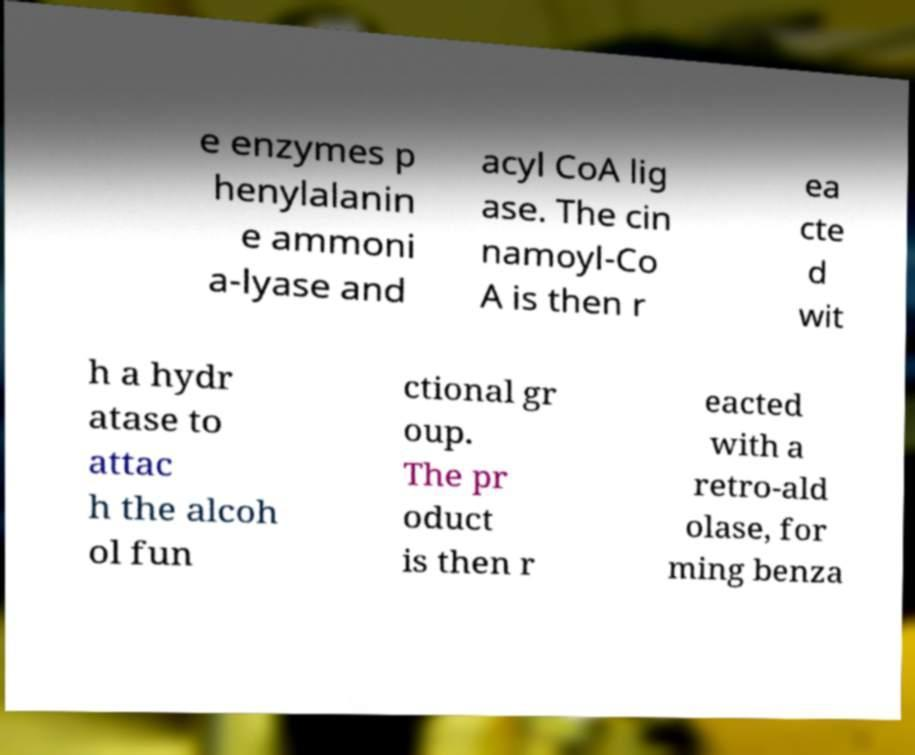I need the written content from this picture converted into text. Can you do that? e enzymes p henylalanin e ammoni a-lyase and acyl CoA lig ase. The cin namoyl-Co A is then r ea cte d wit h a hydr atase to attac h the alcoh ol fun ctional gr oup. The pr oduct is then r eacted with a retro-ald olase, for ming benza 